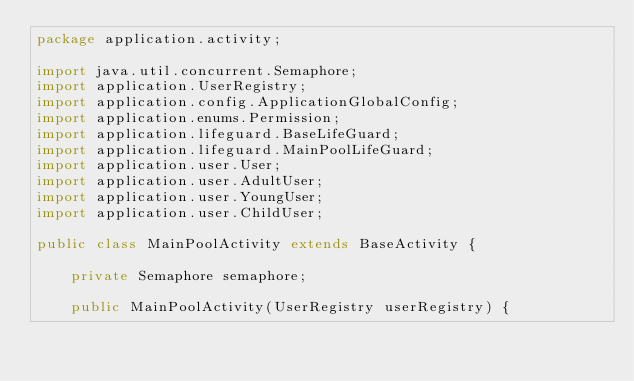<code> <loc_0><loc_0><loc_500><loc_500><_Java_>package application.activity;

import java.util.concurrent.Semaphore;
import application.UserRegistry;
import application.config.ApplicationGlobalConfig;
import application.enums.Permission;
import application.lifeguard.BaseLifeGuard;
import application.lifeguard.MainPoolLifeGuard;
import application.user.User;
import application.user.AdultUser;
import application.user.YoungUser;
import application.user.ChildUser;

public class MainPoolActivity extends BaseActivity {

    private Semaphore semaphore;

    public MainPoolActivity(UserRegistry userRegistry) {</code> 